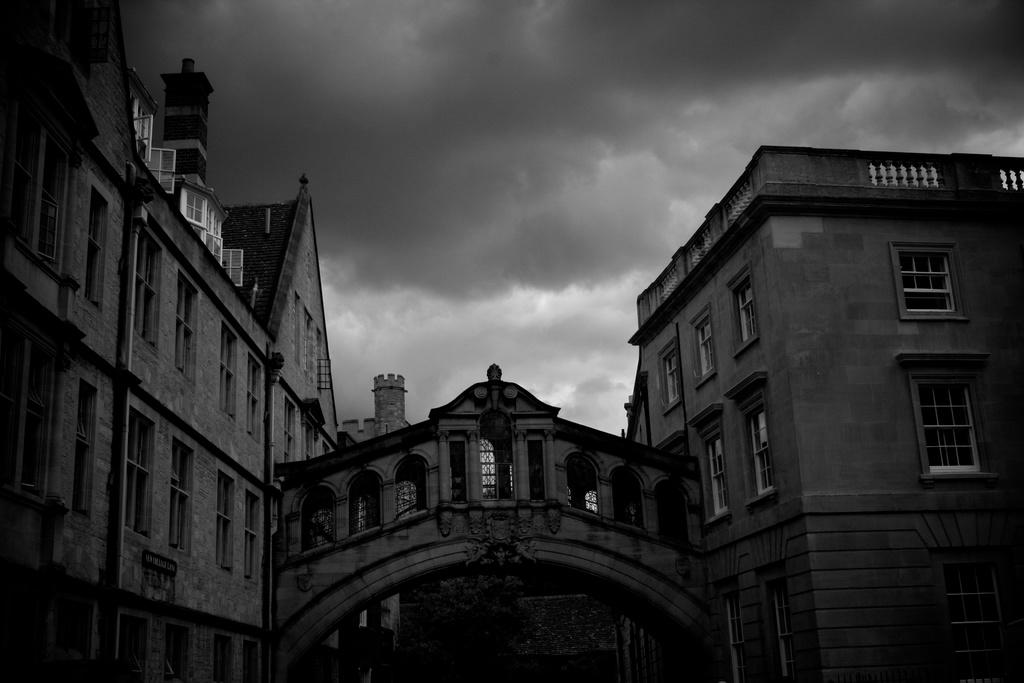What is the main structure visible in the image? There is a big building in the image. Can you describe any additional features of the buildings in the image? Yes, there is a connecting bridge between the buildings in the image. How much profit does the cable generate in the image? There is no cable present in the image, and therefore no profit can be generated from it. 